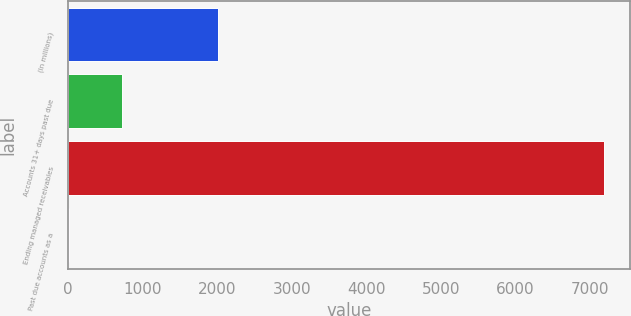<chart> <loc_0><loc_0><loc_500><loc_500><bar_chart><fcel>(In millions)<fcel>Accounts 31+ days past due<fcel>Ending managed receivables<fcel>Past due accounts as a<nl><fcel>2014<fcel>720.76<fcel>7184.4<fcel>2.58<nl></chart> 